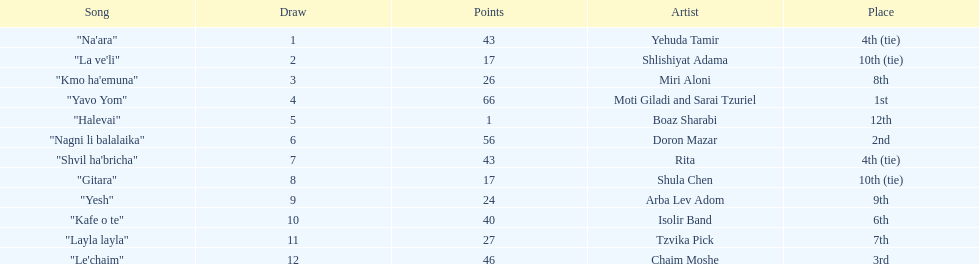What are the number of times an artist earned first place? 1. 